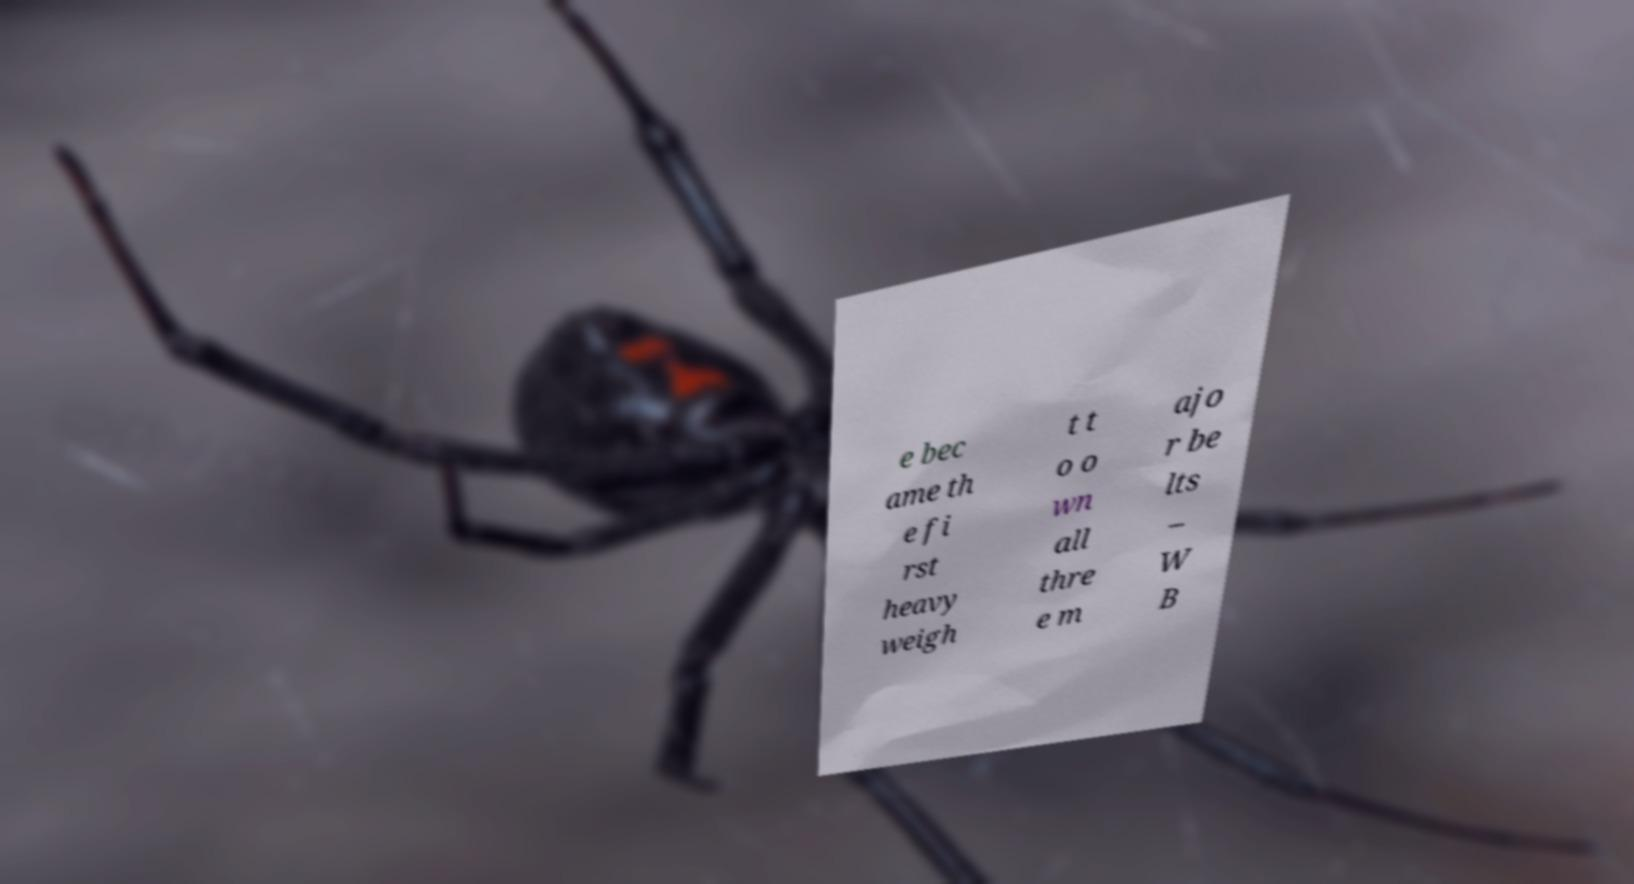Could you extract and type out the text from this image? e bec ame th e fi rst heavy weigh t t o o wn all thre e m ajo r be lts – W B 